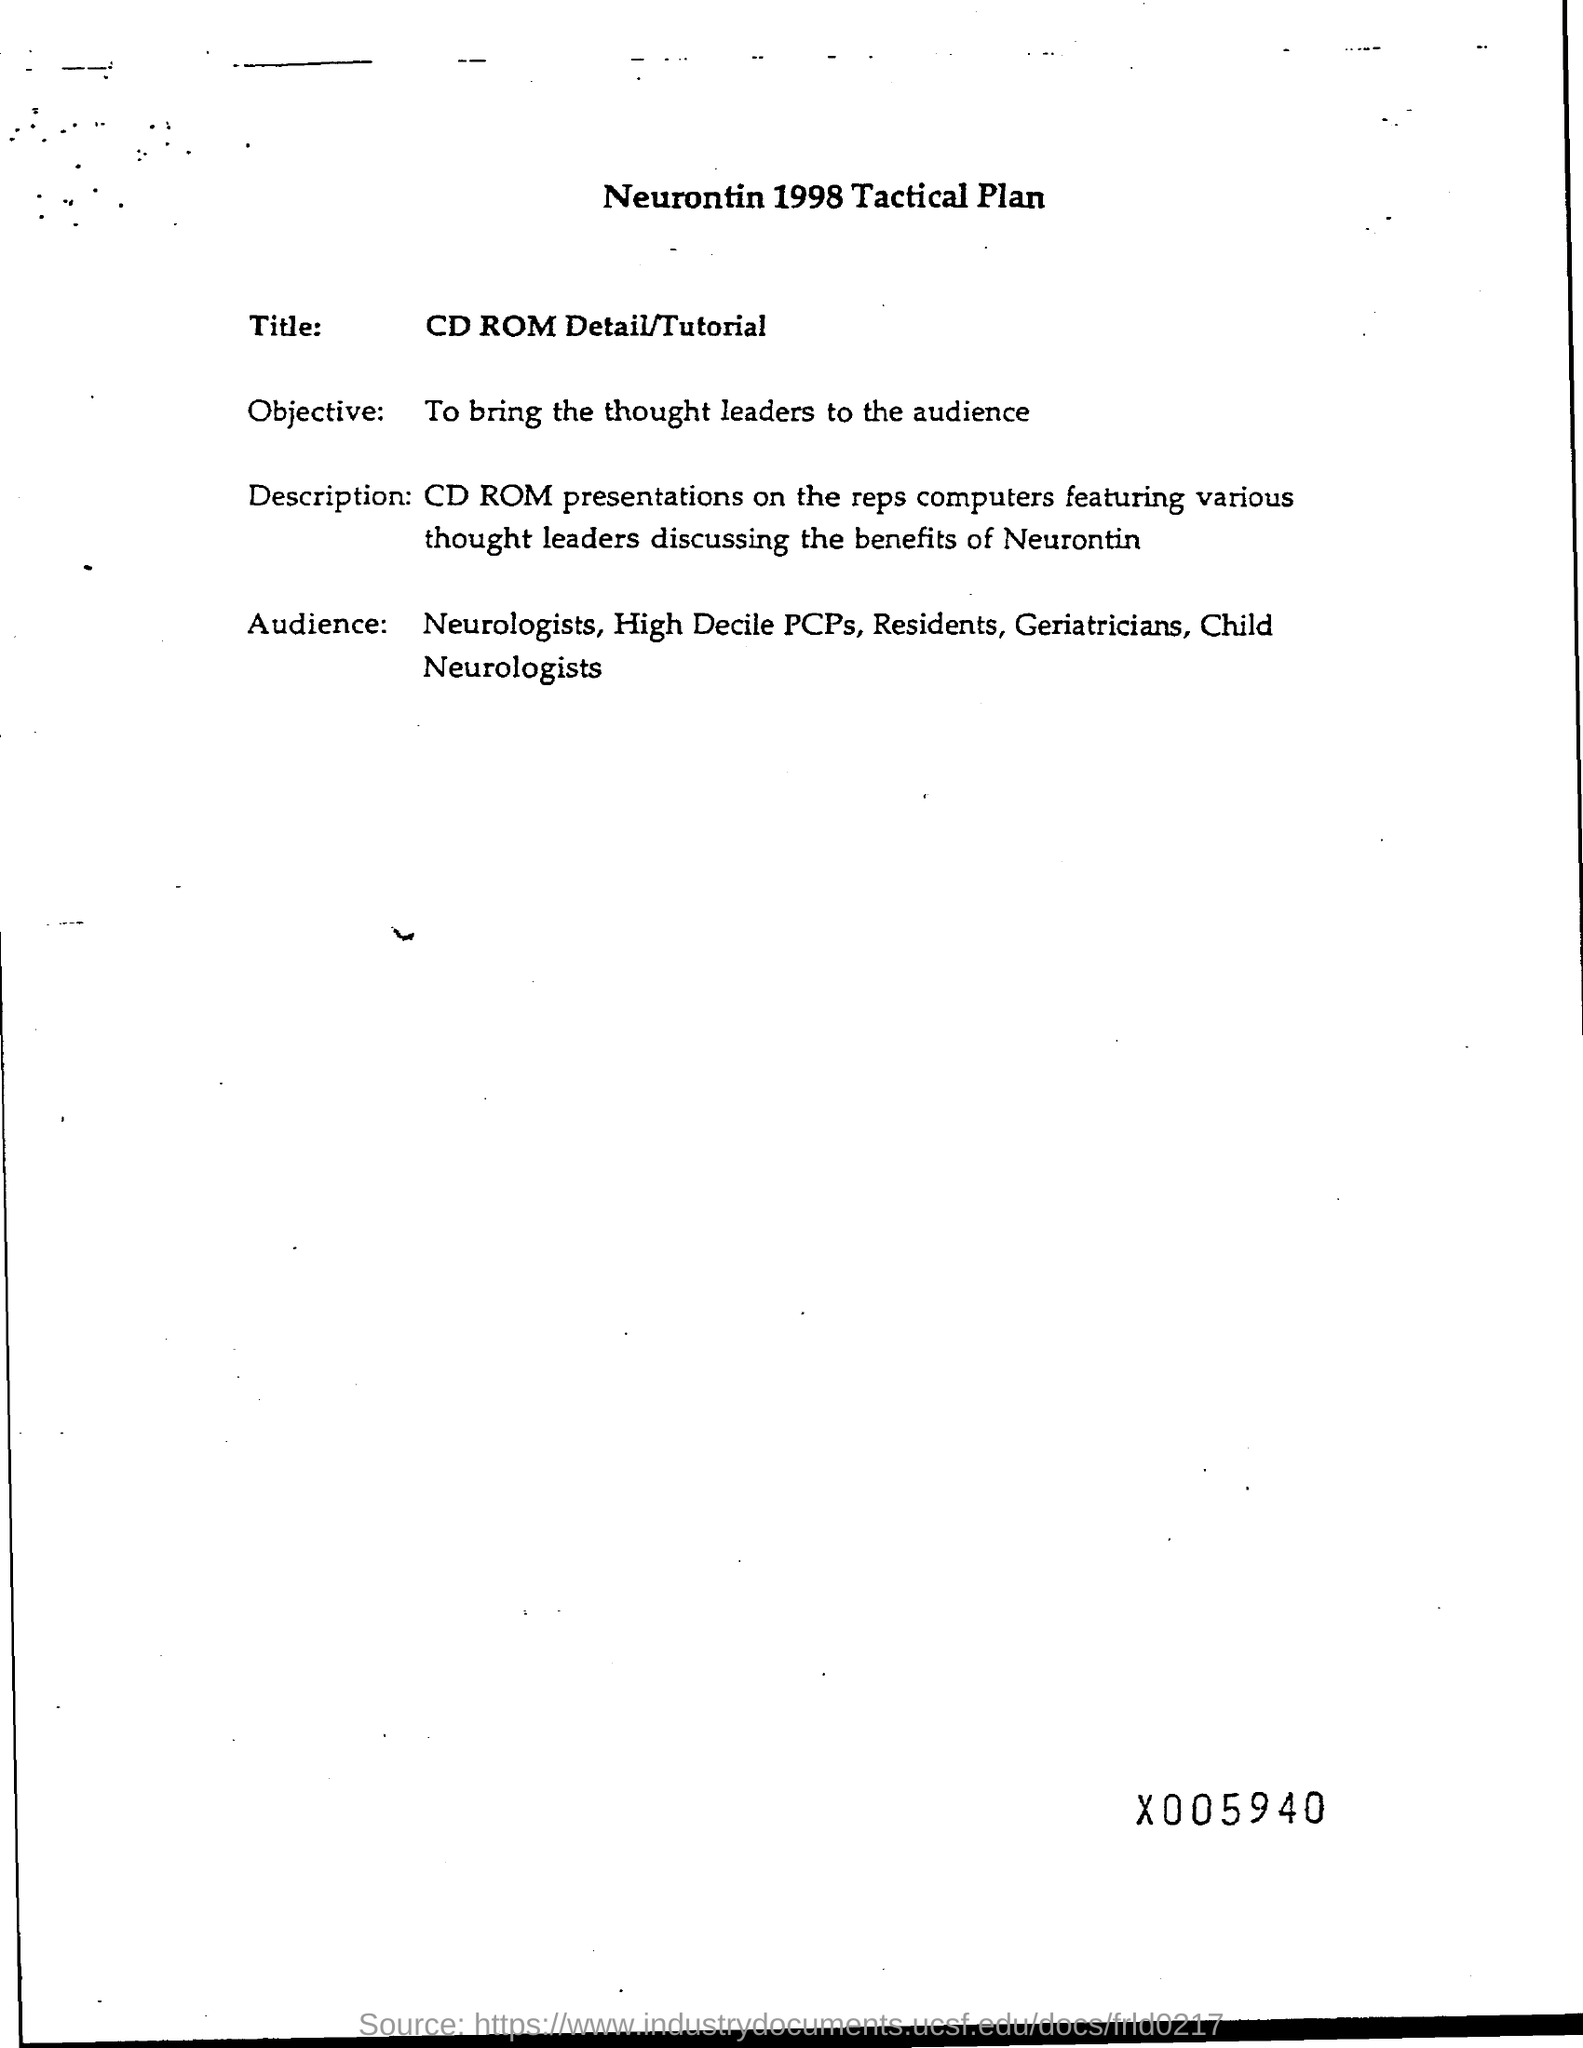Specify some key components in this picture. The title of this CD ROM is a detailed tutorial on its subject matter. 